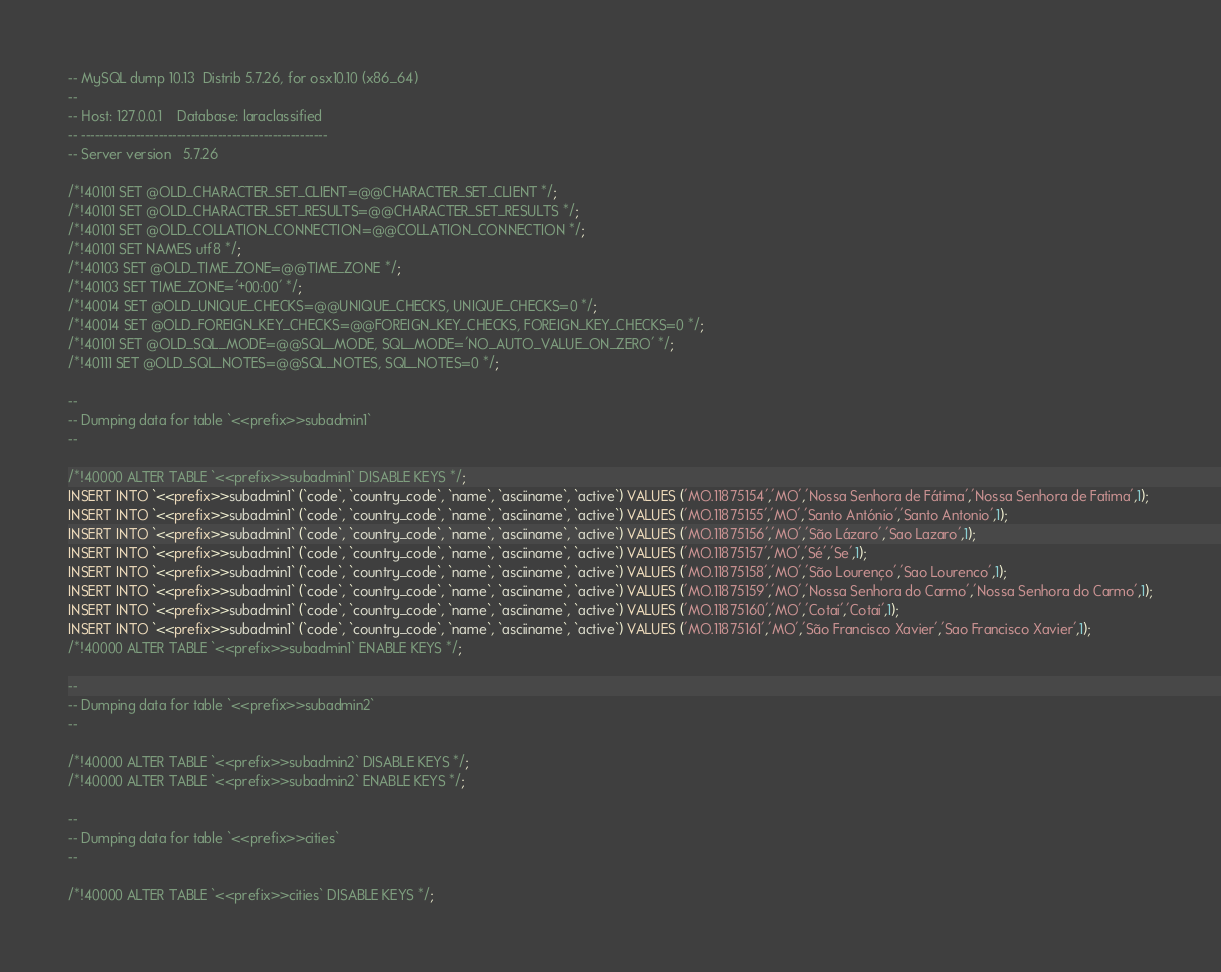<code> <loc_0><loc_0><loc_500><loc_500><_SQL_>-- MySQL dump 10.13  Distrib 5.7.26, for osx10.10 (x86_64)
--
-- Host: 127.0.0.1    Database: laraclassified
-- ------------------------------------------------------
-- Server version	5.7.26

/*!40101 SET @OLD_CHARACTER_SET_CLIENT=@@CHARACTER_SET_CLIENT */;
/*!40101 SET @OLD_CHARACTER_SET_RESULTS=@@CHARACTER_SET_RESULTS */;
/*!40101 SET @OLD_COLLATION_CONNECTION=@@COLLATION_CONNECTION */;
/*!40101 SET NAMES utf8 */;
/*!40103 SET @OLD_TIME_ZONE=@@TIME_ZONE */;
/*!40103 SET TIME_ZONE='+00:00' */;
/*!40014 SET @OLD_UNIQUE_CHECKS=@@UNIQUE_CHECKS, UNIQUE_CHECKS=0 */;
/*!40014 SET @OLD_FOREIGN_KEY_CHECKS=@@FOREIGN_KEY_CHECKS, FOREIGN_KEY_CHECKS=0 */;
/*!40101 SET @OLD_SQL_MODE=@@SQL_MODE, SQL_MODE='NO_AUTO_VALUE_ON_ZERO' */;
/*!40111 SET @OLD_SQL_NOTES=@@SQL_NOTES, SQL_NOTES=0 */;

--
-- Dumping data for table `<<prefix>>subadmin1`
--

/*!40000 ALTER TABLE `<<prefix>>subadmin1` DISABLE KEYS */;
INSERT INTO `<<prefix>>subadmin1` (`code`, `country_code`, `name`, `asciiname`, `active`) VALUES ('MO.11875154','MO','Nossa Senhora de Fátima','Nossa Senhora de Fatima',1);
INSERT INTO `<<prefix>>subadmin1` (`code`, `country_code`, `name`, `asciiname`, `active`) VALUES ('MO.11875155','MO','Santo António','Santo Antonio',1);
INSERT INTO `<<prefix>>subadmin1` (`code`, `country_code`, `name`, `asciiname`, `active`) VALUES ('MO.11875156','MO','São Lázaro','Sao Lazaro',1);
INSERT INTO `<<prefix>>subadmin1` (`code`, `country_code`, `name`, `asciiname`, `active`) VALUES ('MO.11875157','MO','Sé','Se',1);
INSERT INTO `<<prefix>>subadmin1` (`code`, `country_code`, `name`, `asciiname`, `active`) VALUES ('MO.11875158','MO','São Lourenço','Sao Lourenco',1);
INSERT INTO `<<prefix>>subadmin1` (`code`, `country_code`, `name`, `asciiname`, `active`) VALUES ('MO.11875159','MO','Nossa Senhora do Carmo','Nossa Senhora do Carmo',1);
INSERT INTO `<<prefix>>subadmin1` (`code`, `country_code`, `name`, `asciiname`, `active`) VALUES ('MO.11875160','MO','Cotai','Cotai',1);
INSERT INTO `<<prefix>>subadmin1` (`code`, `country_code`, `name`, `asciiname`, `active`) VALUES ('MO.11875161','MO','São Francisco Xavier','Sao Francisco Xavier',1);
/*!40000 ALTER TABLE `<<prefix>>subadmin1` ENABLE KEYS */;

--
-- Dumping data for table `<<prefix>>subadmin2`
--

/*!40000 ALTER TABLE `<<prefix>>subadmin2` DISABLE KEYS */;
/*!40000 ALTER TABLE `<<prefix>>subadmin2` ENABLE KEYS */;

--
-- Dumping data for table `<<prefix>>cities`
--

/*!40000 ALTER TABLE `<<prefix>>cities` DISABLE KEYS */;</code> 